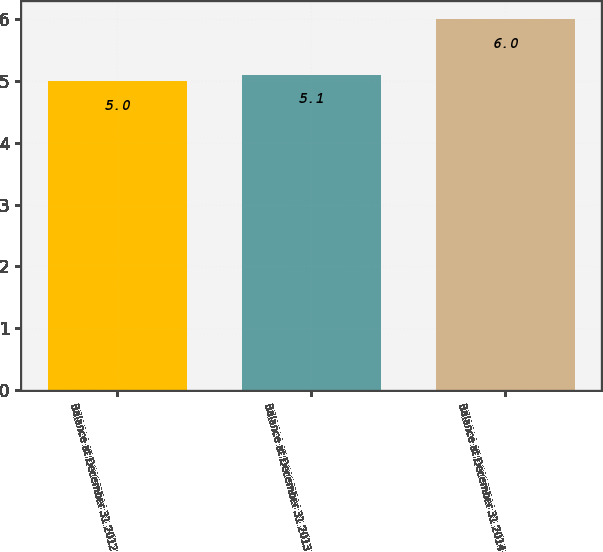Convert chart. <chart><loc_0><loc_0><loc_500><loc_500><bar_chart><fcel>Balance at December 31 2012<fcel>Balance at December 31 2013<fcel>Balance at December 31 2014<nl><fcel>5<fcel>5.1<fcel>6<nl></chart> 